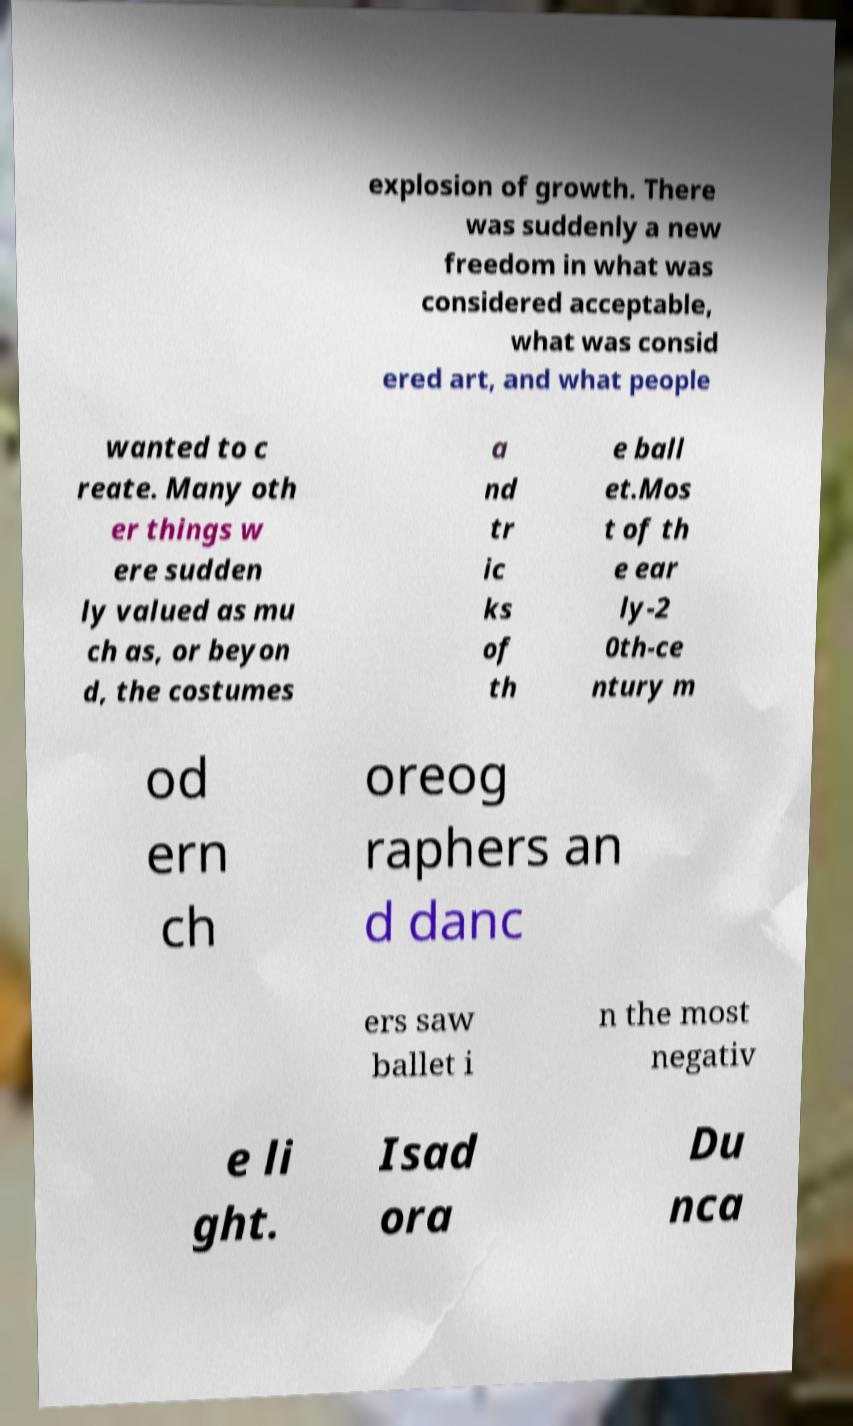For documentation purposes, I need the text within this image transcribed. Could you provide that? explosion of growth. There was suddenly a new freedom in what was considered acceptable, what was consid ered art, and what people wanted to c reate. Many oth er things w ere sudden ly valued as mu ch as, or beyon d, the costumes a nd tr ic ks of th e ball et.Mos t of th e ear ly-2 0th-ce ntury m od ern ch oreog raphers an d danc ers saw ballet i n the most negativ e li ght. Isad ora Du nca 